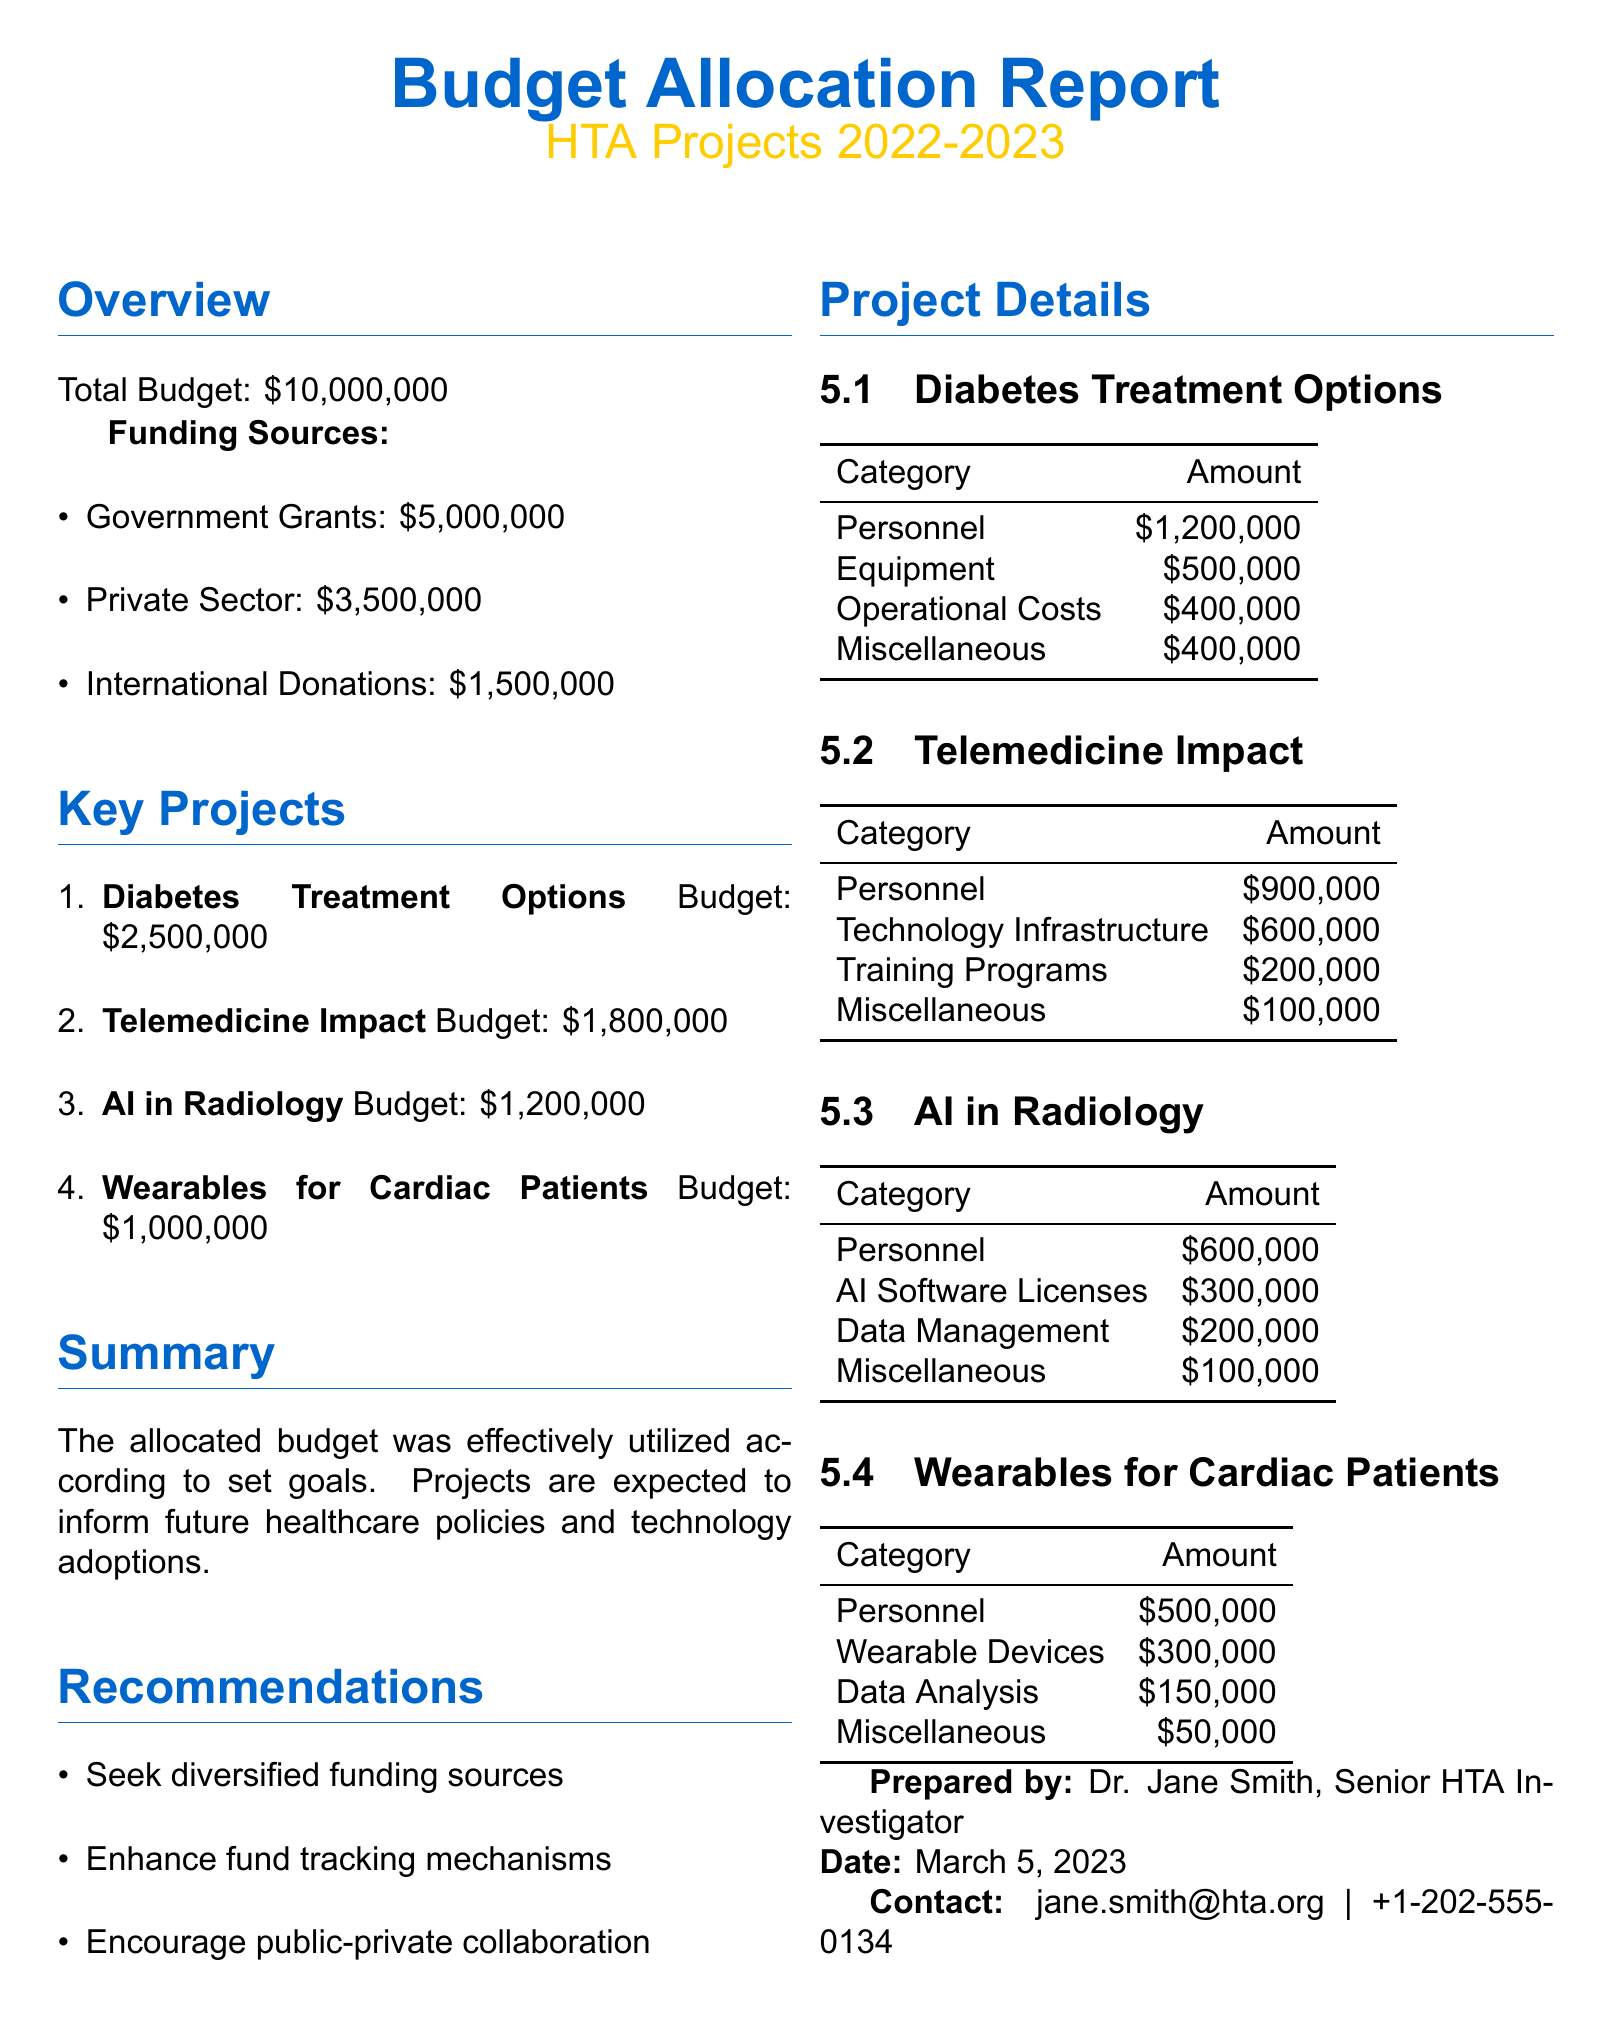What is the total budget for HTA Projects 2022-2023? The total budget is explicitly stated at the beginning of the document.
Answer: $10,000,000 How much funding came from Government Grants? The funding sources are listed, and Government Grants show the amount specified in the document.
Answer: $5,000,000 What is the budget allocated for the Diabetes Treatment Options project? The budget for each key project is listed alongside their names.
Answer: $2,500,000 What category had the highest expenditure in the Telemedicine Impact project? The details of each project outline expenditures by category, with personnel being the highest in this project.
Answer: Personnel How much was allocated for AI Software Licenses in the AI in Radiology project? The expenditure categories in the project details specify individual amounts.
Answer: $300,000 What is one of the recommendations listed in the report? The recommendations section contains specific suggestions, which can be pulled directly from the text.
Answer: Seek diversified funding sources Which project had the lowest budget allocated? Budgets are listed for each project, allowing for a comparison to determine which one has the least funding.
Answer: Wearables for Cardiac Patients Who prepared the report? The document includes the name of the person who prepared the report at the end.
Answer: Dr. Jane Smith What is the date of the report's preparation? The preparation date is clearly provided in the contact information section at the end of the document.
Answer: March 5, 2023 